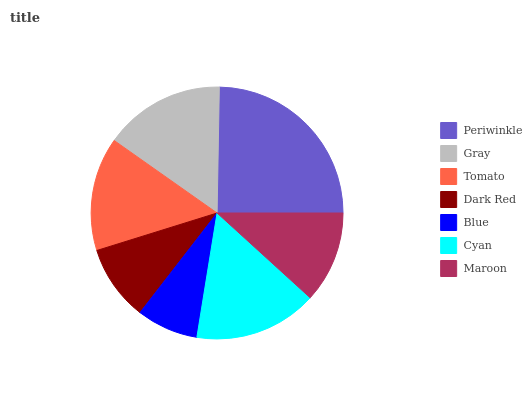Is Blue the minimum?
Answer yes or no. Yes. Is Periwinkle the maximum?
Answer yes or no. Yes. Is Gray the minimum?
Answer yes or no. No. Is Gray the maximum?
Answer yes or no. No. Is Periwinkle greater than Gray?
Answer yes or no. Yes. Is Gray less than Periwinkle?
Answer yes or no. Yes. Is Gray greater than Periwinkle?
Answer yes or no. No. Is Periwinkle less than Gray?
Answer yes or no. No. Is Tomato the high median?
Answer yes or no. Yes. Is Tomato the low median?
Answer yes or no. Yes. Is Gray the high median?
Answer yes or no. No. Is Periwinkle the low median?
Answer yes or no. No. 